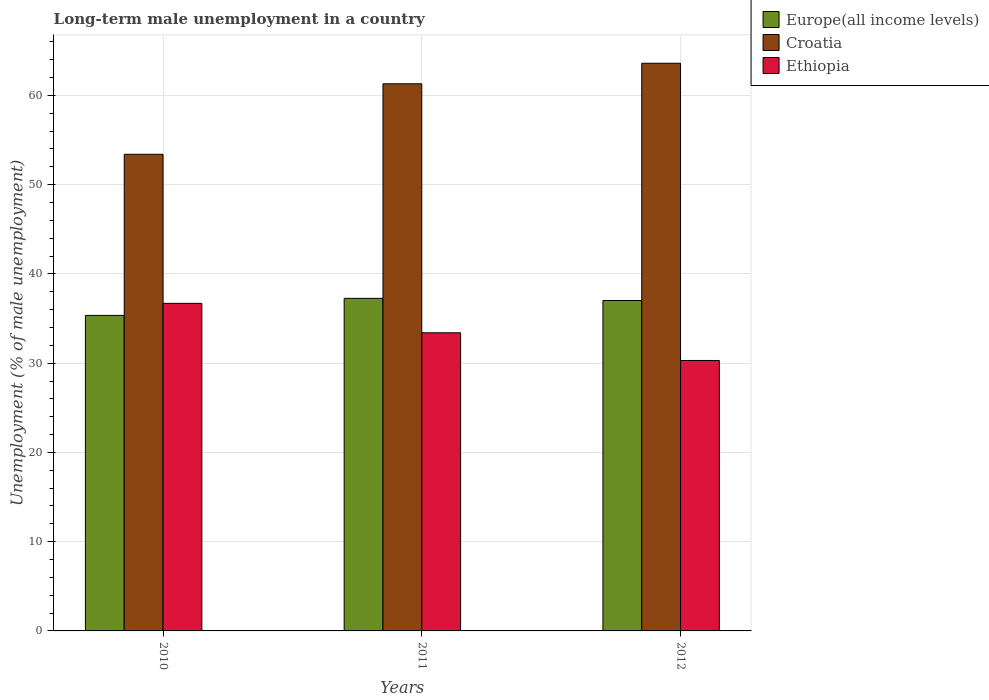How many different coloured bars are there?
Give a very brief answer. 3. Are the number of bars on each tick of the X-axis equal?
Make the answer very short. Yes. How many bars are there on the 3rd tick from the left?
Your answer should be very brief. 3. How many bars are there on the 1st tick from the right?
Make the answer very short. 3. What is the label of the 2nd group of bars from the left?
Provide a succinct answer. 2011. What is the percentage of long-term unemployed male population in Ethiopia in 2012?
Your answer should be very brief. 30.3. Across all years, what is the maximum percentage of long-term unemployed male population in Croatia?
Ensure brevity in your answer.  63.6. Across all years, what is the minimum percentage of long-term unemployed male population in Croatia?
Provide a short and direct response. 53.4. In which year was the percentage of long-term unemployed male population in Croatia minimum?
Offer a very short reply. 2010. What is the total percentage of long-term unemployed male population in Ethiopia in the graph?
Your answer should be compact. 100.4. What is the difference between the percentage of long-term unemployed male population in Ethiopia in 2010 and that in 2011?
Give a very brief answer. 3.3. What is the difference between the percentage of long-term unemployed male population in Ethiopia in 2011 and the percentage of long-term unemployed male population in Europe(all income levels) in 2010?
Your answer should be very brief. -1.95. What is the average percentage of long-term unemployed male population in Croatia per year?
Your answer should be very brief. 59.43. In the year 2010, what is the difference between the percentage of long-term unemployed male population in Croatia and percentage of long-term unemployed male population in Europe(all income levels)?
Your response must be concise. 18.05. In how many years, is the percentage of long-term unemployed male population in Ethiopia greater than 30 %?
Provide a succinct answer. 3. What is the ratio of the percentage of long-term unemployed male population in Croatia in 2011 to that in 2012?
Ensure brevity in your answer.  0.96. Is the percentage of long-term unemployed male population in Croatia in 2011 less than that in 2012?
Provide a succinct answer. Yes. Is the difference between the percentage of long-term unemployed male population in Croatia in 2010 and 2012 greater than the difference between the percentage of long-term unemployed male population in Europe(all income levels) in 2010 and 2012?
Your answer should be compact. No. What is the difference between the highest and the second highest percentage of long-term unemployed male population in Ethiopia?
Your answer should be compact. 3.3. What is the difference between the highest and the lowest percentage of long-term unemployed male population in Croatia?
Offer a very short reply. 10.2. In how many years, is the percentage of long-term unemployed male population in Ethiopia greater than the average percentage of long-term unemployed male population in Ethiopia taken over all years?
Your answer should be compact. 1. Is the sum of the percentage of long-term unemployed male population in Ethiopia in 2010 and 2011 greater than the maximum percentage of long-term unemployed male population in Croatia across all years?
Give a very brief answer. Yes. What does the 1st bar from the left in 2011 represents?
Your answer should be very brief. Europe(all income levels). What does the 1st bar from the right in 2011 represents?
Make the answer very short. Ethiopia. Is it the case that in every year, the sum of the percentage of long-term unemployed male population in Ethiopia and percentage of long-term unemployed male population in Croatia is greater than the percentage of long-term unemployed male population in Europe(all income levels)?
Keep it short and to the point. Yes. How many bars are there?
Offer a terse response. 9. Are all the bars in the graph horizontal?
Make the answer very short. No. What is the difference between two consecutive major ticks on the Y-axis?
Make the answer very short. 10. Are the values on the major ticks of Y-axis written in scientific E-notation?
Provide a succinct answer. No. Does the graph contain grids?
Offer a very short reply. Yes. What is the title of the graph?
Offer a terse response. Long-term male unemployment in a country. What is the label or title of the Y-axis?
Provide a short and direct response. Unemployment (% of male unemployment). What is the Unemployment (% of male unemployment) in Europe(all income levels) in 2010?
Give a very brief answer. 35.35. What is the Unemployment (% of male unemployment) in Croatia in 2010?
Provide a succinct answer. 53.4. What is the Unemployment (% of male unemployment) in Ethiopia in 2010?
Your answer should be compact. 36.7. What is the Unemployment (% of male unemployment) in Europe(all income levels) in 2011?
Your answer should be compact. 37.26. What is the Unemployment (% of male unemployment) of Croatia in 2011?
Your answer should be very brief. 61.3. What is the Unemployment (% of male unemployment) of Ethiopia in 2011?
Keep it short and to the point. 33.4. What is the Unemployment (% of male unemployment) of Europe(all income levels) in 2012?
Your answer should be very brief. 37.02. What is the Unemployment (% of male unemployment) in Croatia in 2012?
Give a very brief answer. 63.6. What is the Unemployment (% of male unemployment) of Ethiopia in 2012?
Ensure brevity in your answer.  30.3. Across all years, what is the maximum Unemployment (% of male unemployment) in Europe(all income levels)?
Provide a succinct answer. 37.26. Across all years, what is the maximum Unemployment (% of male unemployment) of Croatia?
Provide a succinct answer. 63.6. Across all years, what is the maximum Unemployment (% of male unemployment) in Ethiopia?
Your response must be concise. 36.7. Across all years, what is the minimum Unemployment (% of male unemployment) in Europe(all income levels)?
Offer a very short reply. 35.35. Across all years, what is the minimum Unemployment (% of male unemployment) of Croatia?
Keep it short and to the point. 53.4. Across all years, what is the minimum Unemployment (% of male unemployment) in Ethiopia?
Offer a terse response. 30.3. What is the total Unemployment (% of male unemployment) of Europe(all income levels) in the graph?
Your answer should be very brief. 109.63. What is the total Unemployment (% of male unemployment) in Croatia in the graph?
Keep it short and to the point. 178.3. What is the total Unemployment (% of male unemployment) of Ethiopia in the graph?
Keep it short and to the point. 100.4. What is the difference between the Unemployment (% of male unemployment) in Europe(all income levels) in 2010 and that in 2011?
Offer a very short reply. -1.91. What is the difference between the Unemployment (% of male unemployment) in Ethiopia in 2010 and that in 2011?
Provide a short and direct response. 3.3. What is the difference between the Unemployment (% of male unemployment) in Europe(all income levels) in 2010 and that in 2012?
Provide a succinct answer. -1.67. What is the difference between the Unemployment (% of male unemployment) in Europe(all income levels) in 2011 and that in 2012?
Ensure brevity in your answer.  0.24. What is the difference between the Unemployment (% of male unemployment) of Europe(all income levels) in 2010 and the Unemployment (% of male unemployment) of Croatia in 2011?
Ensure brevity in your answer.  -25.95. What is the difference between the Unemployment (% of male unemployment) of Europe(all income levels) in 2010 and the Unemployment (% of male unemployment) of Ethiopia in 2011?
Provide a short and direct response. 1.95. What is the difference between the Unemployment (% of male unemployment) of Europe(all income levels) in 2010 and the Unemployment (% of male unemployment) of Croatia in 2012?
Ensure brevity in your answer.  -28.25. What is the difference between the Unemployment (% of male unemployment) in Europe(all income levels) in 2010 and the Unemployment (% of male unemployment) in Ethiopia in 2012?
Your answer should be very brief. 5.05. What is the difference between the Unemployment (% of male unemployment) of Croatia in 2010 and the Unemployment (% of male unemployment) of Ethiopia in 2012?
Ensure brevity in your answer.  23.1. What is the difference between the Unemployment (% of male unemployment) of Europe(all income levels) in 2011 and the Unemployment (% of male unemployment) of Croatia in 2012?
Ensure brevity in your answer.  -26.34. What is the difference between the Unemployment (% of male unemployment) of Europe(all income levels) in 2011 and the Unemployment (% of male unemployment) of Ethiopia in 2012?
Keep it short and to the point. 6.96. What is the difference between the Unemployment (% of male unemployment) of Croatia in 2011 and the Unemployment (% of male unemployment) of Ethiopia in 2012?
Offer a very short reply. 31. What is the average Unemployment (% of male unemployment) of Europe(all income levels) per year?
Provide a short and direct response. 36.54. What is the average Unemployment (% of male unemployment) of Croatia per year?
Ensure brevity in your answer.  59.43. What is the average Unemployment (% of male unemployment) in Ethiopia per year?
Make the answer very short. 33.47. In the year 2010, what is the difference between the Unemployment (% of male unemployment) of Europe(all income levels) and Unemployment (% of male unemployment) of Croatia?
Make the answer very short. -18.05. In the year 2010, what is the difference between the Unemployment (% of male unemployment) in Europe(all income levels) and Unemployment (% of male unemployment) in Ethiopia?
Keep it short and to the point. -1.35. In the year 2011, what is the difference between the Unemployment (% of male unemployment) of Europe(all income levels) and Unemployment (% of male unemployment) of Croatia?
Make the answer very short. -24.04. In the year 2011, what is the difference between the Unemployment (% of male unemployment) of Europe(all income levels) and Unemployment (% of male unemployment) of Ethiopia?
Offer a very short reply. 3.86. In the year 2011, what is the difference between the Unemployment (% of male unemployment) of Croatia and Unemployment (% of male unemployment) of Ethiopia?
Keep it short and to the point. 27.9. In the year 2012, what is the difference between the Unemployment (% of male unemployment) in Europe(all income levels) and Unemployment (% of male unemployment) in Croatia?
Make the answer very short. -26.58. In the year 2012, what is the difference between the Unemployment (% of male unemployment) of Europe(all income levels) and Unemployment (% of male unemployment) of Ethiopia?
Keep it short and to the point. 6.72. In the year 2012, what is the difference between the Unemployment (% of male unemployment) in Croatia and Unemployment (% of male unemployment) in Ethiopia?
Offer a terse response. 33.3. What is the ratio of the Unemployment (% of male unemployment) in Europe(all income levels) in 2010 to that in 2011?
Your response must be concise. 0.95. What is the ratio of the Unemployment (% of male unemployment) in Croatia in 2010 to that in 2011?
Give a very brief answer. 0.87. What is the ratio of the Unemployment (% of male unemployment) in Ethiopia in 2010 to that in 2011?
Provide a short and direct response. 1.1. What is the ratio of the Unemployment (% of male unemployment) in Europe(all income levels) in 2010 to that in 2012?
Offer a very short reply. 0.95. What is the ratio of the Unemployment (% of male unemployment) of Croatia in 2010 to that in 2012?
Keep it short and to the point. 0.84. What is the ratio of the Unemployment (% of male unemployment) in Ethiopia in 2010 to that in 2012?
Keep it short and to the point. 1.21. What is the ratio of the Unemployment (% of male unemployment) of Europe(all income levels) in 2011 to that in 2012?
Keep it short and to the point. 1.01. What is the ratio of the Unemployment (% of male unemployment) in Croatia in 2011 to that in 2012?
Give a very brief answer. 0.96. What is the ratio of the Unemployment (% of male unemployment) in Ethiopia in 2011 to that in 2012?
Keep it short and to the point. 1.1. What is the difference between the highest and the second highest Unemployment (% of male unemployment) of Europe(all income levels)?
Offer a terse response. 0.24. What is the difference between the highest and the second highest Unemployment (% of male unemployment) of Croatia?
Keep it short and to the point. 2.3. What is the difference between the highest and the second highest Unemployment (% of male unemployment) of Ethiopia?
Your answer should be very brief. 3.3. What is the difference between the highest and the lowest Unemployment (% of male unemployment) in Europe(all income levels)?
Your answer should be very brief. 1.91. What is the difference between the highest and the lowest Unemployment (% of male unemployment) in Croatia?
Ensure brevity in your answer.  10.2. What is the difference between the highest and the lowest Unemployment (% of male unemployment) of Ethiopia?
Make the answer very short. 6.4. 